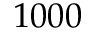Convert formula to latex. <formula><loc_0><loc_0><loc_500><loc_500>1 0 0 0</formula> 